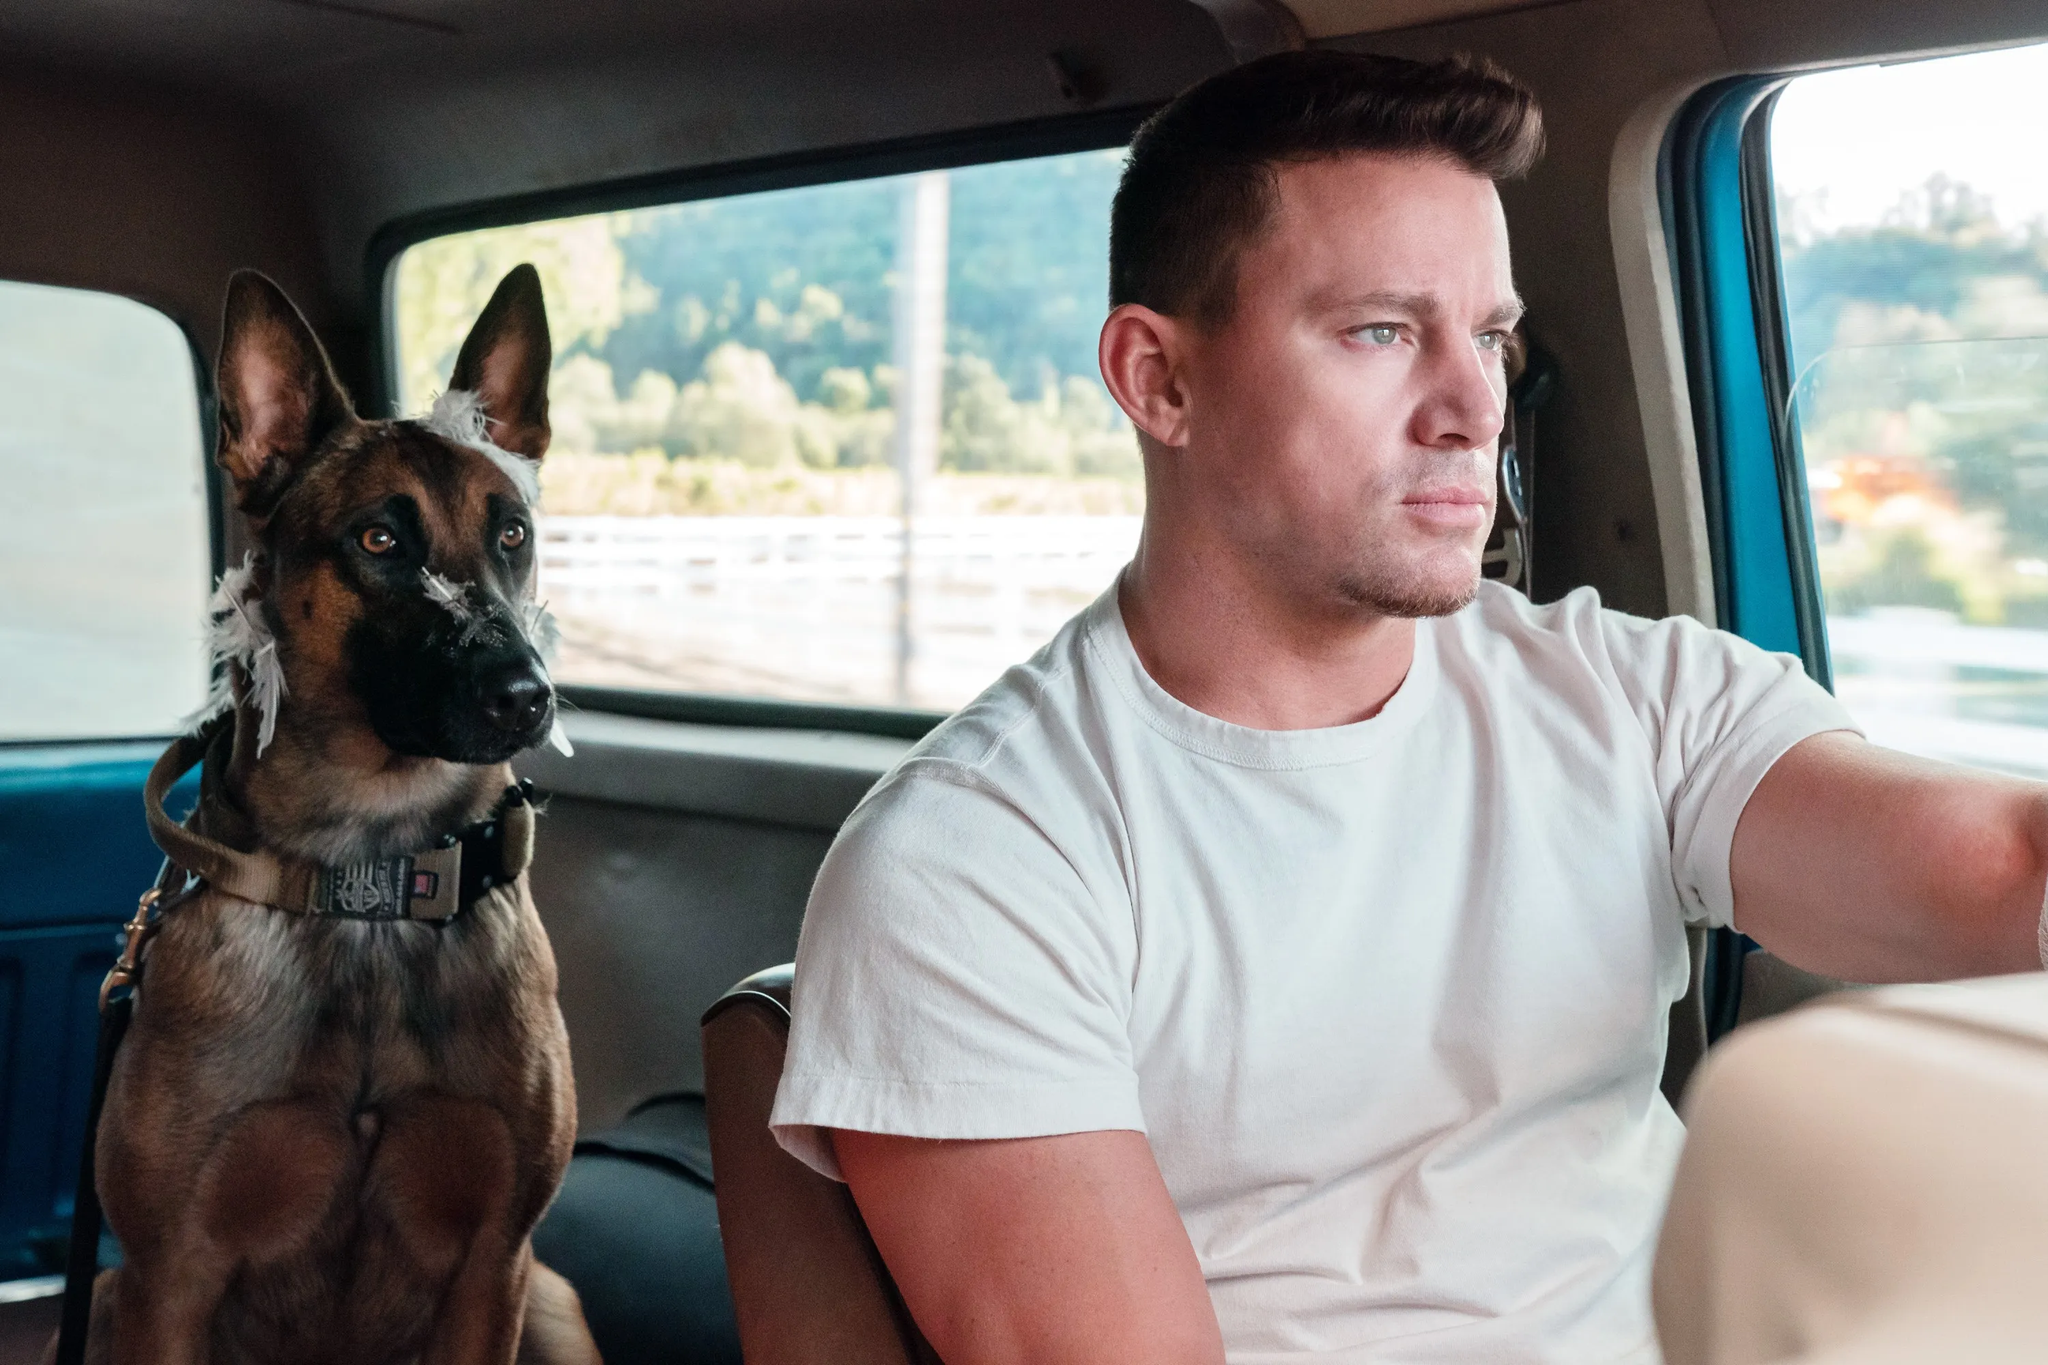Can you create a poetic interpretation of this image? In the quiet hum of a passing day, 
On winding roads where shadows play, 
A man and his faithful friend, side by side, 
Together on this joyful ride. 
Through panes of glass, the world blurs by, 
Trees and skies, they twist and fly. 
With a loyal heart and steady hand, 
They traverse this boundless land. 
Silence speaks in volumes loud, 
Trust in a bond that's never bowed. 
Man and beast, they journey free, 
In simple, shared serenity. 